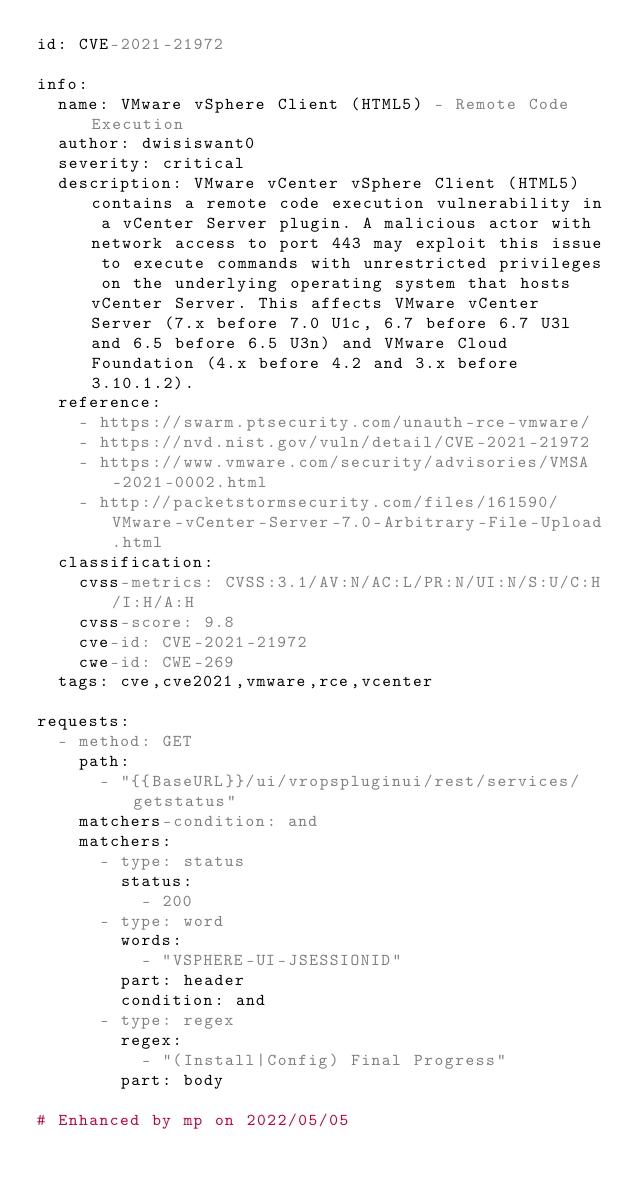Convert code to text. <code><loc_0><loc_0><loc_500><loc_500><_YAML_>id: CVE-2021-21972

info:
  name: VMware vSphere Client (HTML5) - Remote Code Execution
  author: dwisiswant0
  severity: critical
  description: VMware vCenter vSphere Client (HTML5) contains a remote code execution vulnerability in a vCenter Server plugin. A malicious actor with network access to port 443 may exploit this issue to execute commands with unrestricted privileges on the underlying operating system that hosts vCenter Server. This affects VMware vCenter Server (7.x before 7.0 U1c, 6.7 before 6.7 U3l and 6.5 before 6.5 U3n) and VMware Cloud Foundation (4.x before 4.2 and 3.x before 3.10.1.2).
  reference:
    - https://swarm.ptsecurity.com/unauth-rce-vmware/
    - https://nvd.nist.gov/vuln/detail/CVE-2021-21972
    - https://www.vmware.com/security/advisories/VMSA-2021-0002.html
    - http://packetstormsecurity.com/files/161590/VMware-vCenter-Server-7.0-Arbitrary-File-Upload.html
  classification:
    cvss-metrics: CVSS:3.1/AV:N/AC:L/PR:N/UI:N/S:U/C:H/I:H/A:H
    cvss-score: 9.8
    cve-id: CVE-2021-21972
    cwe-id: CWE-269
  tags: cve,cve2021,vmware,rce,vcenter

requests:
  - method: GET
    path:
      - "{{BaseURL}}/ui/vropspluginui/rest/services/getstatus"
    matchers-condition: and
    matchers:
      - type: status
        status:
          - 200
      - type: word
        words:
          - "VSPHERE-UI-JSESSIONID"
        part: header
        condition: and
      - type: regex
        regex:
          - "(Install|Config) Final Progress"
        part: body

# Enhanced by mp on 2022/05/05
</code> 